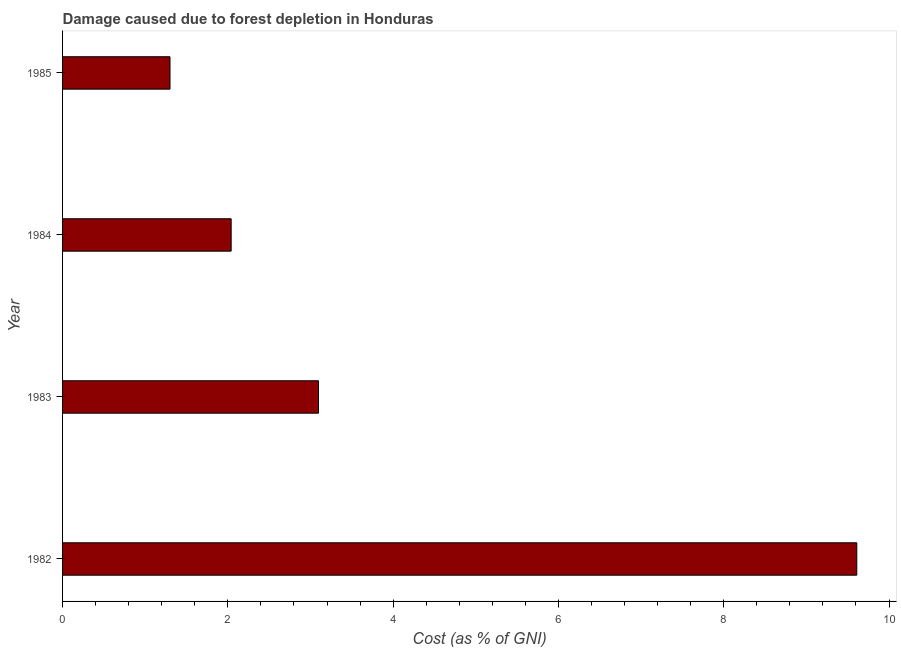Does the graph contain any zero values?
Provide a short and direct response. No. Does the graph contain grids?
Provide a short and direct response. No. What is the title of the graph?
Provide a succinct answer. Damage caused due to forest depletion in Honduras. What is the label or title of the X-axis?
Your response must be concise. Cost (as % of GNI). What is the label or title of the Y-axis?
Your answer should be very brief. Year. What is the damage caused due to forest depletion in 1983?
Offer a very short reply. 3.1. Across all years, what is the maximum damage caused due to forest depletion?
Offer a very short reply. 9.61. Across all years, what is the minimum damage caused due to forest depletion?
Provide a succinct answer. 1.3. In which year was the damage caused due to forest depletion maximum?
Make the answer very short. 1982. In which year was the damage caused due to forest depletion minimum?
Make the answer very short. 1985. What is the sum of the damage caused due to forest depletion?
Offer a very short reply. 16.05. What is the difference between the damage caused due to forest depletion in 1983 and 1985?
Give a very brief answer. 1.8. What is the average damage caused due to forest depletion per year?
Offer a terse response. 4.01. What is the median damage caused due to forest depletion?
Your answer should be very brief. 2.57. Do a majority of the years between 1984 and 1982 (inclusive) have damage caused due to forest depletion greater than 4 %?
Provide a succinct answer. Yes. What is the ratio of the damage caused due to forest depletion in 1982 to that in 1984?
Make the answer very short. 4.71. Is the damage caused due to forest depletion in 1982 less than that in 1985?
Provide a short and direct response. No. Is the difference between the damage caused due to forest depletion in 1983 and 1985 greater than the difference between any two years?
Make the answer very short. No. What is the difference between the highest and the second highest damage caused due to forest depletion?
Offer a very short reply. 6.51. Is the sum of the damage caused due to forest depletion in 1983 and 1985 greater than the maximum damage caused due to forest depletion across all years?
Ensure brevity in your answer.  No. What is the difference between the highest and the lowest damage caused due to forest depletion?
Make the answer very short. 8.31. In how many years, is the damage caused due to forest depletion greater than the average damage caused due to forest depletion taken over all years?
Offer a terse response. 1. How many years are there in the graph?
Offer a very short reply. 4. What is the difference between two consecutive major ticks on the X-axis?
Provide a short and direct response. 2. What is the Cost (as % of GNI) in 1982?
Offer a very short reply. 9.61. What is the Cost (as % of GNI) in 1983?
Provide a short and direct response. 3.1. What is the Cost (as % of GNI) in 1984?
Ensure brevity in your answer.  2.04. What is the Cost (as % of GNI) of 1985?
Keep it short and to the point. 1.3. What is the difference between the Cost (as % of GNI) in 1982 and 1983?
Give a very brief answer. 6.51. What is the difference between the Cost (as % of GNI) in 1982 and 1984?
Your response must be concise. 7.57. What is the difference between the Cost (as % of GNI) in 1982 and 1985?
Offer a terse response. 8.31. What is the difference between the Cost (as % of GNI) in 1983 and 1984?
Provide a succinct answer. 1.06. What is the difference between the Cost (as % of GNI) in 1983 and 1985?
Make the answer very short. 1.8. What is the difference between the Cost (as % of GNI) in 1984 and 1985?
Your answer should be compact. 0.74. What is the ratio of the Cost (as % of GNI) in 1982 to that in 1983?
Your answer should be compact. 3.1. What is the ratio of the Cost (as % of GNI) in 1982 to that in 1984?
Provide a short and direct response. 4.71. What is the ratio of the Cost (as % of GNI) in 1982 to that in 1985?
Provide a short and direct response. 7.39. What is the ratio of the Cost (as % of GNI) in 1983 to that in 1984?
Provide a short and direct response. 1.52. What is the ratio of the Cost (as % of GNI) in 1983 to that in 1985?
Your answer should be very brief. 2.38. What is the ratio of the Cost (as % of GNI) in 1984 to that in 1985?
Provide a short and direct response. 1.57. 